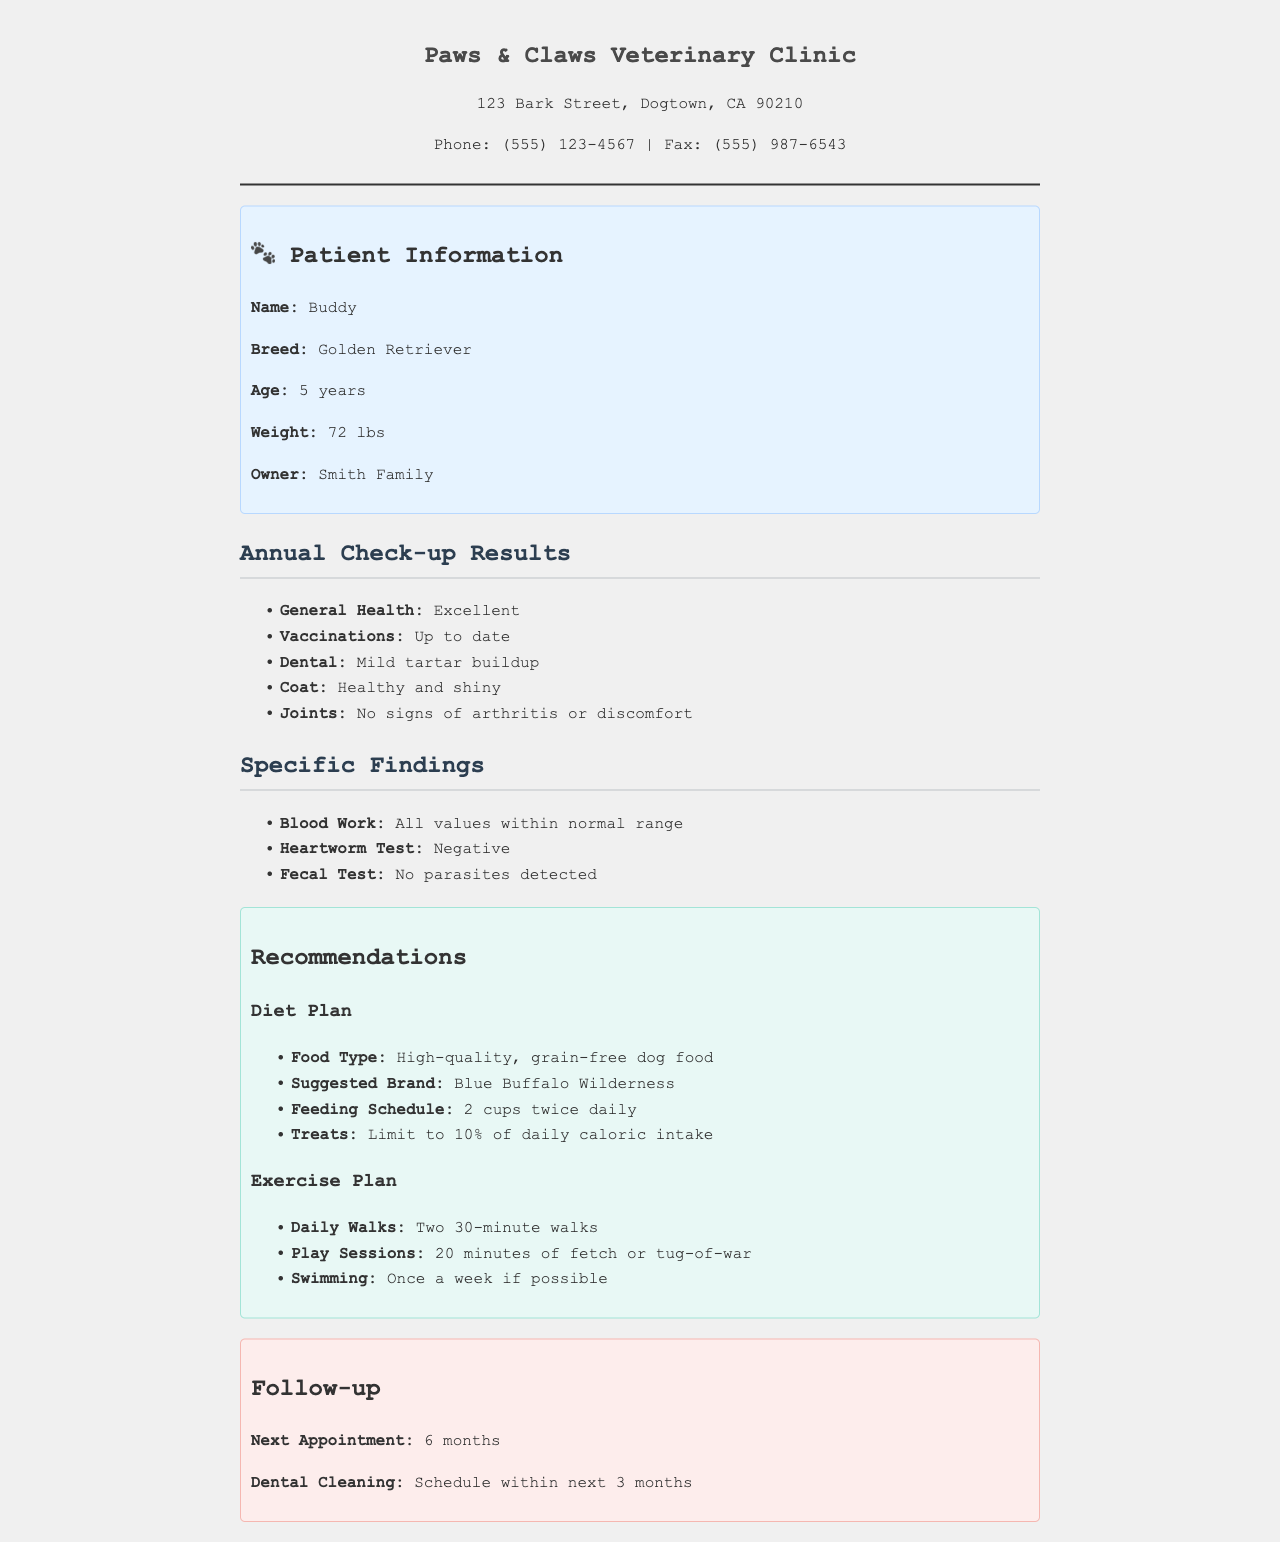what is the name of the dog? The dog's name is provided in the patient information section of the document.
Answer: Buddy what is the breed of the dog? The breed is mentioned in the patient information section.
Answer: Golden Retriever how much does the dog weigh? The weight is listed in the patient information section.
Answer: 72 lbs what is the general health status of the dog? The general health status is indicated in the annual check-up results section.
Answer: Excellent how many cups of food should the dog be fed twice daily? The feeding schedule provides specific quantities for the dog's diet.
Answer: 2 cups what brand of dog food is suggested? The suggested brand is clearly stated in the recommendations section under the diet plan.
Answer: Blue Buffalo Wilderness when is the next appointment scheduled? The follow-up section specifies when the next appointment is.
Answer: 6 months how many minutes of play sessions are recommended? The exercise plan outlines the duration of play sessions.
Answer: 20 minutes what type of dietary treats is recommended? The recommendations specify the nature of dietary treats.
Answer: Limit to 10% of daily caloric intake 